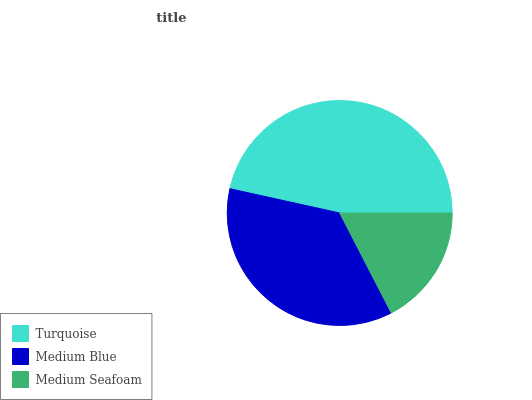Is Medium Seafoam the minimum?
Answer yes or no. Yes. Is Turquoise the maximum?
Answer yes or no. Yes. Is Medium Blue the minimum?
Answer yes or no. No. Is Medium Blue the maximum?
Answer yes or no. No. Is Turquoise greater than Medium Blue?
Answer yes or no. Yes. Is Medium Blue less than Turquoise?
Answer yes or no. Yes. Is Medium Blue greater than Turquoise?
Answer yes or no. No. Is Turquoise less than Medium Blue?
Answer yes or no. No. Is Medium Blue the high median?
Answer yes or no. Yes. Is Medium Blue the low median?
Answer yes or no. Yes. Is Medium Seafoam the high median?
Answer yes or no. No. Is Turquoise the low median?
Answer yes or no. No. 